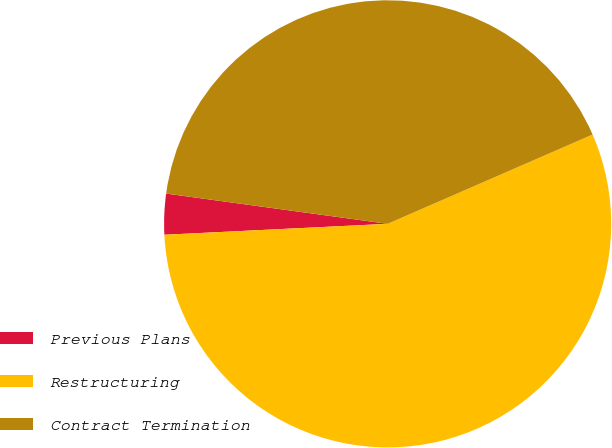Convert chart to OTSL. <chart><loc_0><loc_0><loc_500><loc_500><pie_chart><fcel>Previous Plans<fcel>Restructuring<fcel>Contract Termination<nl><fcel>2.94%<fcel>55.76%<fcel>41.3%<nl></chart> 